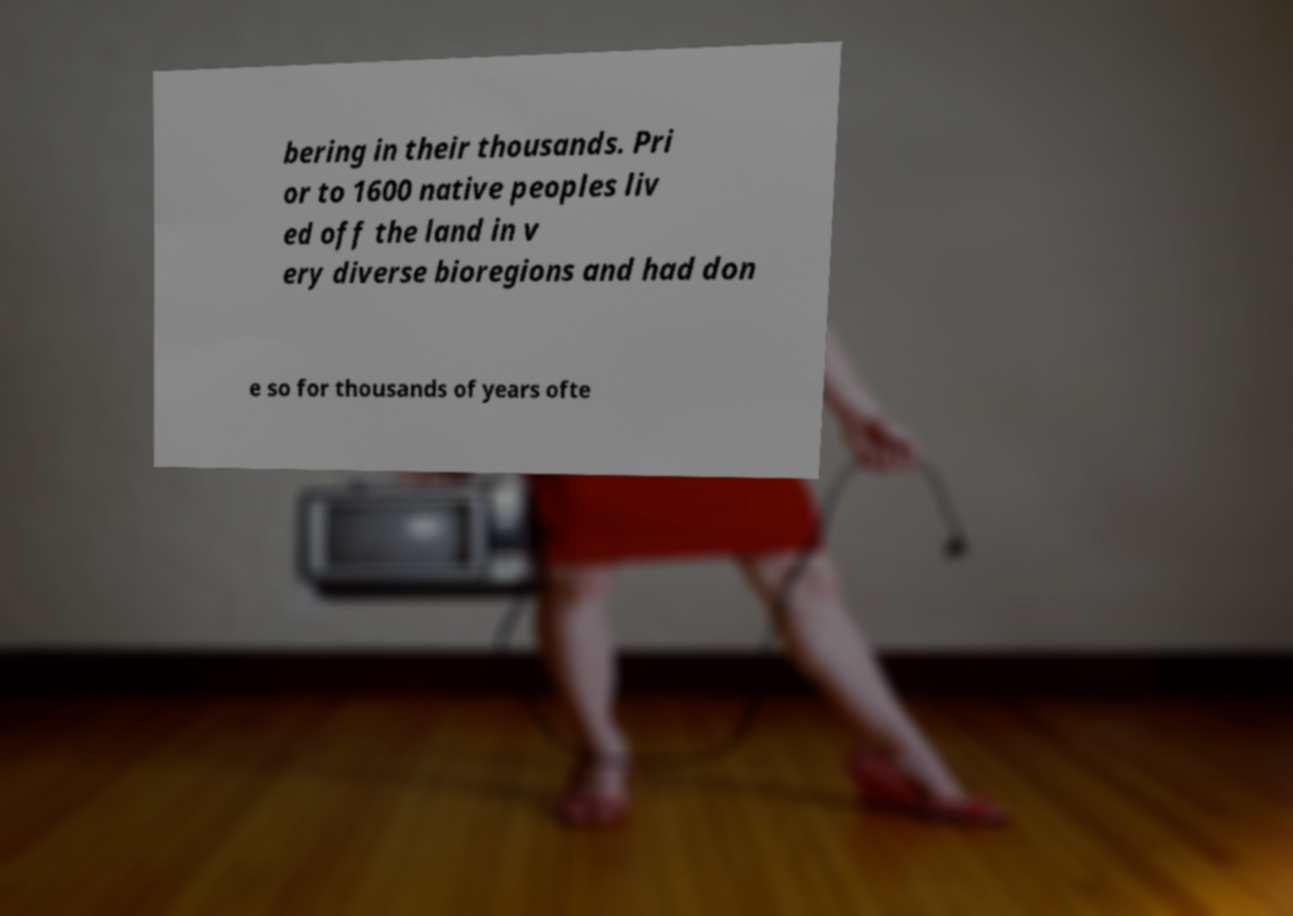I need the written content from this picture converted into text. Can you do that? bering in their thousands. Pri or to 1600 native peoples liv ed off the land in v ery diverse bioregions and had don e so for thousands of years ofte 